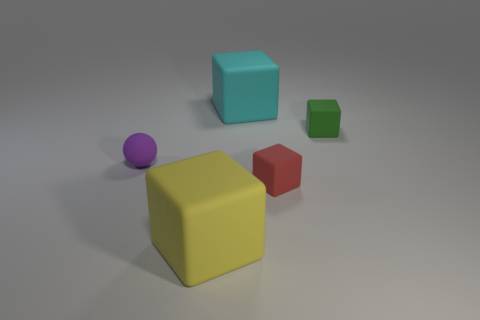Subtract all small red rubber cubes. How many cubes are left? 3 Add 3 tiny rubber blocks. How many objects exist? 8 Subtract all cyan blocks. How many blocks are left? 3 Subtract 1 balls. How many balls are left? 0 Subtract all spheres. How many objects are left? 4 Subtract all purple blocks. Subtract all yellow spheres. How many blocks are left? 4 Subtract all large purple cylinders. Subtract all red rubber cubes. How many objects are left? 4 Add 3 yellow cubes. How many yellow cubes are left? 4 Add 5 large yellow things. How many large yellow things exist? 6 Subtract 0 cyan cylinders. How many objects are left? 5 